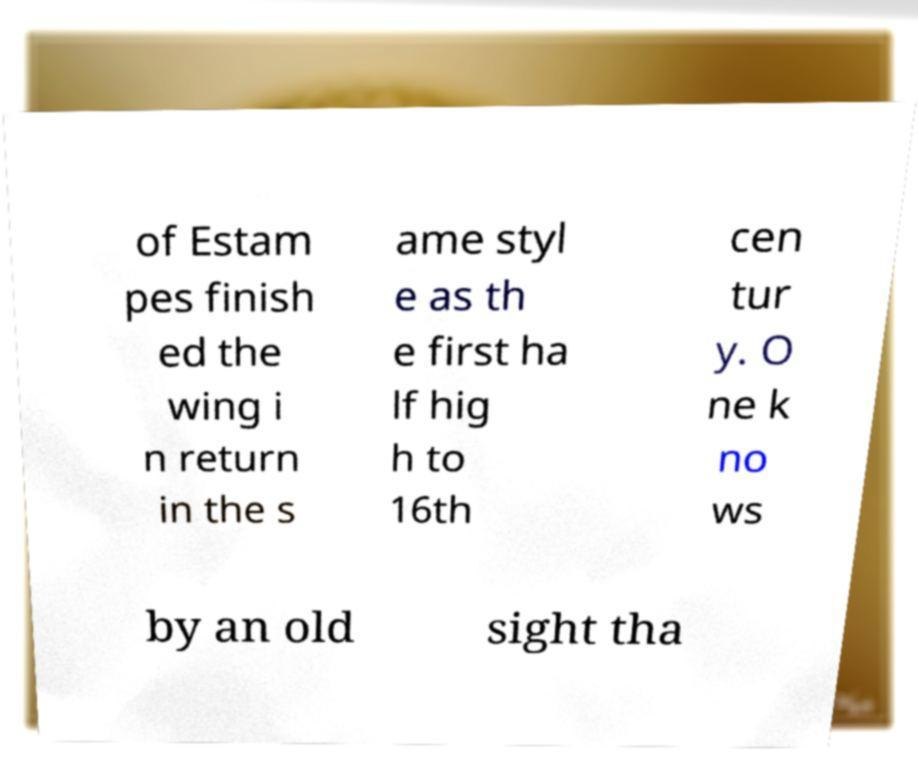Please read and relay the text visible in this image. What does it say? of Estam pes finish ed the wing i n return in the s ame styl e as th e first ha lf hig h to 16th cen tur y. O ne k no ws by an old sight tha 